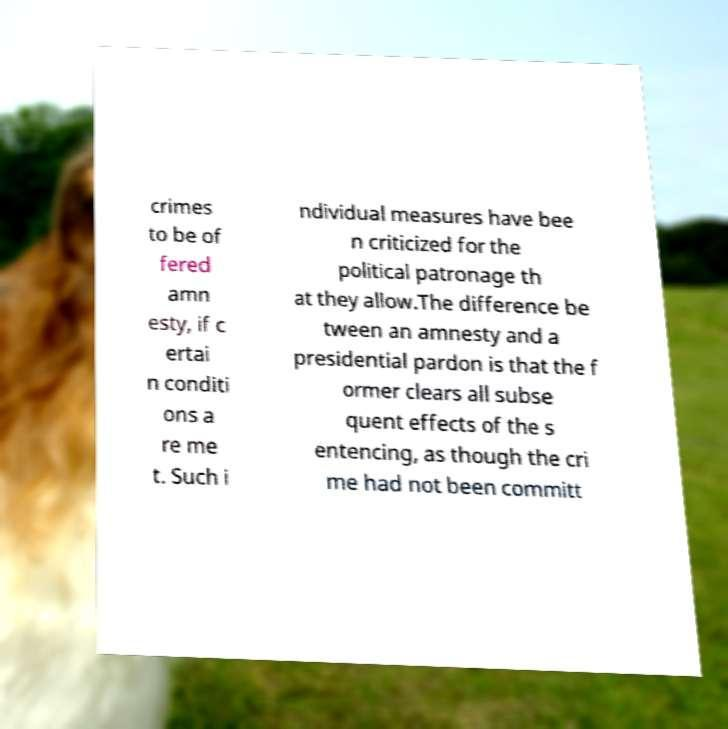Could you extract and type out the text from this image? crimes to be of fered amn esty, if c ertai n conditi ons a re me t. Such i ndividual measures have bee n criticized for the political patronage th at they allow.The difference be tween an amnesty and a presidential pardon is that the f ormer clears all subse quent effects of the s entencing, as though the cri me had not been committ 